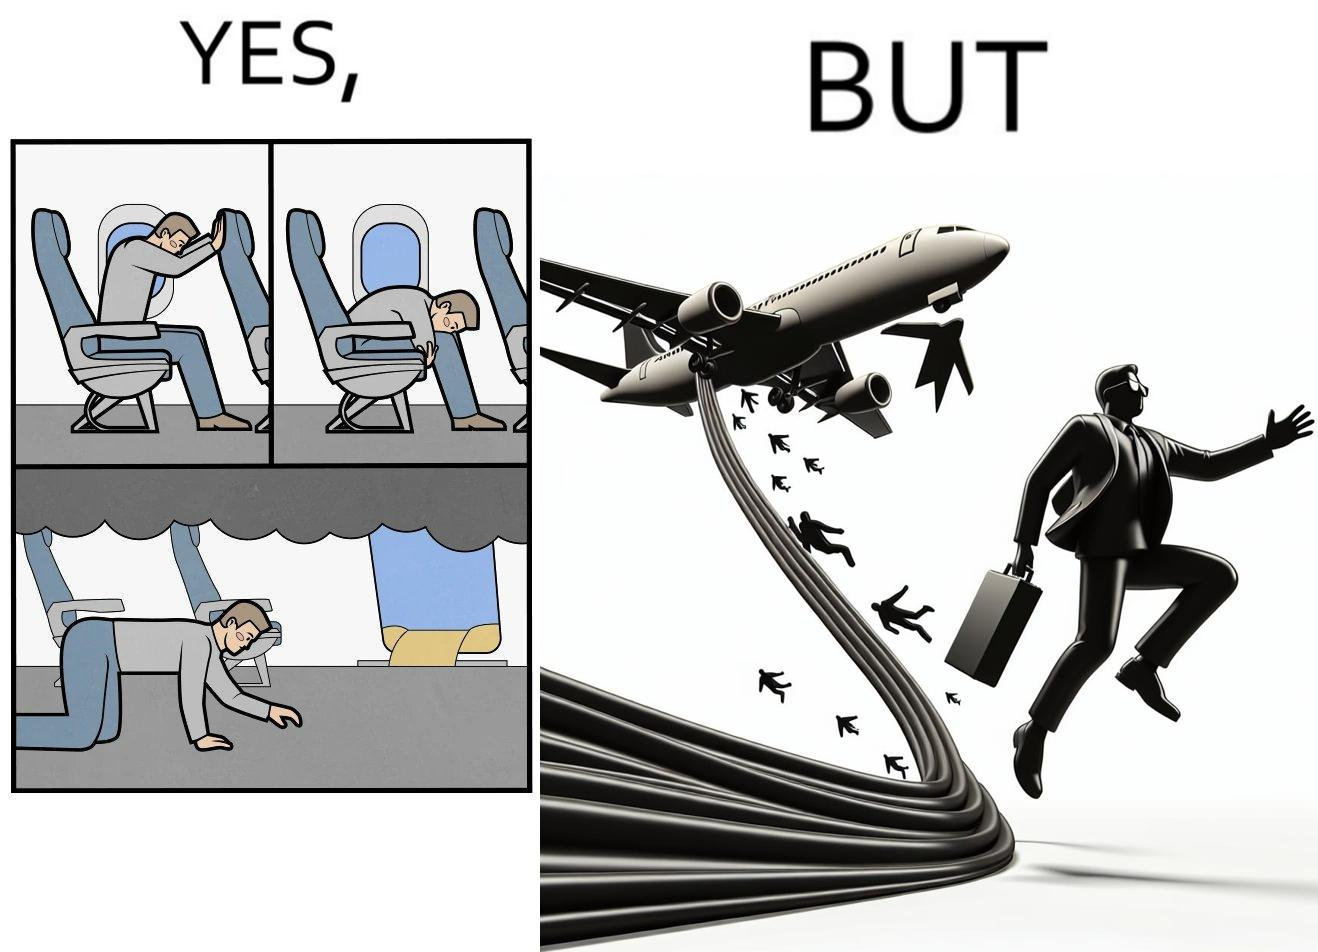What does this image depict? These images are funny since it shows how we are taught emergency procedures to follow in case of an accident while in an airplane but how none of them work if the plane is still in air 